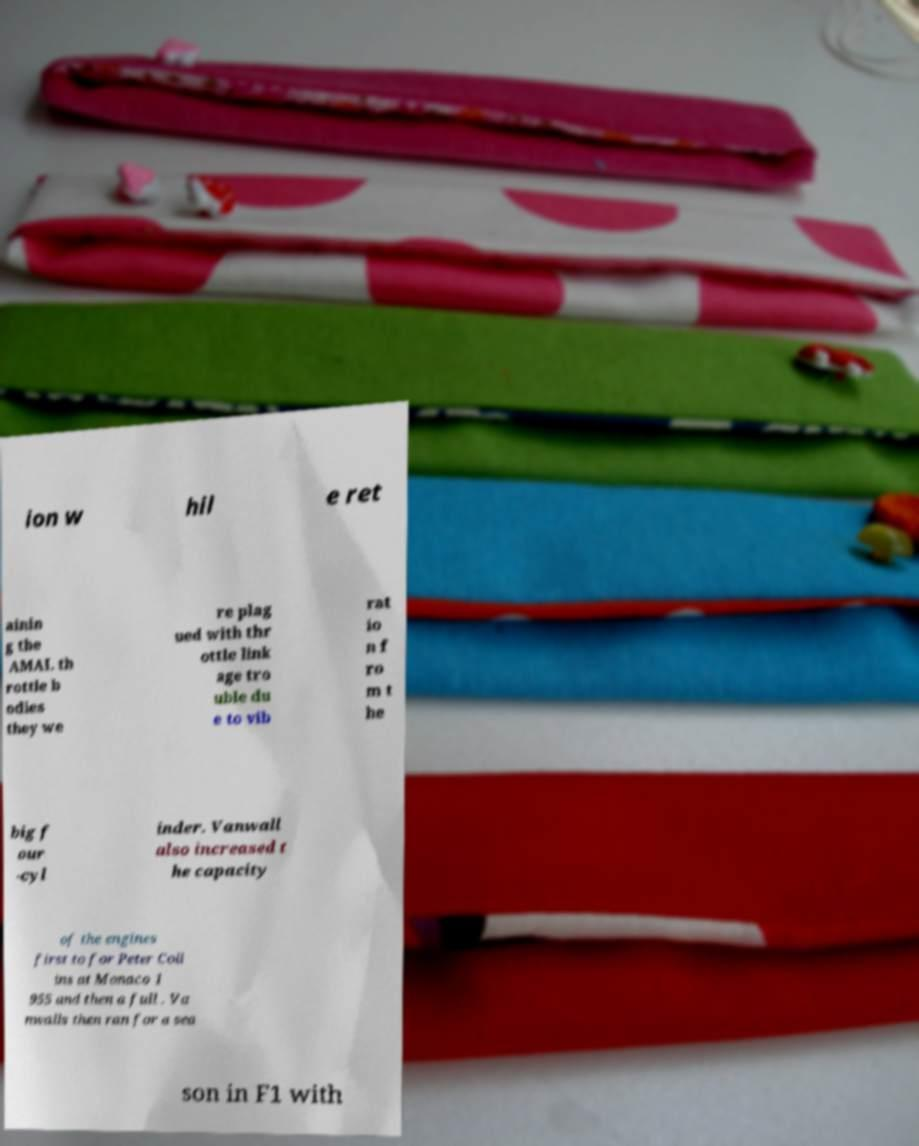Could you extract and type out the text from this image? ion w hil e ret ainin g the AMAL th rottle b odies they we re plag ued with thr ottle link age tro uble du e to vib rat io n f ro m t he big f our -cyl inder. Vanwall also increased t he capacity of the engines first to for Peter Coll ins at Monaco 1 955 and then a full . Va nwalls then ran for a sea son in F1 with 